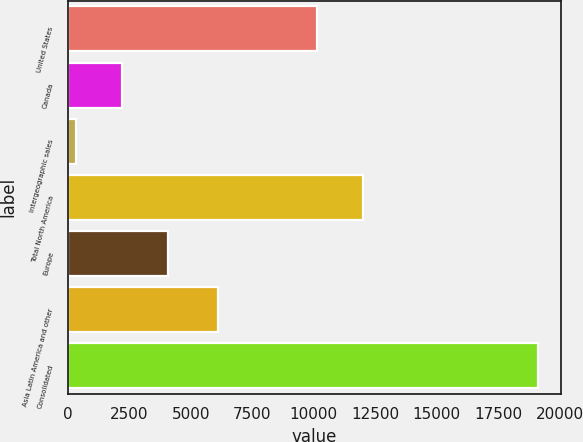Convert chart to OTSL. <chart><loc_0><loc_0><loc_500><loc_500><bar_chart><fcel>United States<fcel>Canada<fcel>Intergeographic sales<fcel>Total North America<fcel>Europe<fcel>Asia Latin America and other<fcel>Consolidated<nl><fcel>10146<fcel>2201.3<fcel>322<fcel>12025.3<fcel>4080.6<fcel>6124<fcel>19115<nl></chart> 